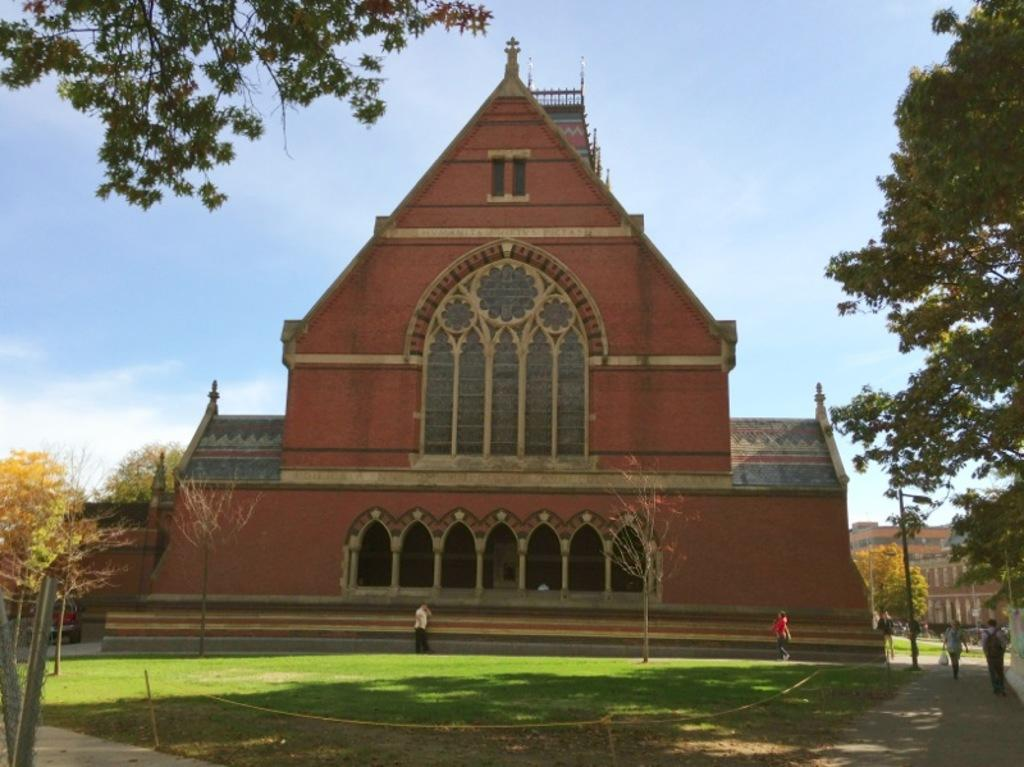How many people are in the image? There is a group of people in the image. What structures can be seen in the image? There are buildings in the image. What type of natural elements are present in the image? There are trees in the image. What can be seen in the distance in the image? The sky is visible in the background of the image. What type of decision is being made by the trees in the image? There are no decisions being made by the trees in the image, as trees do not have the ability to make decisions. 